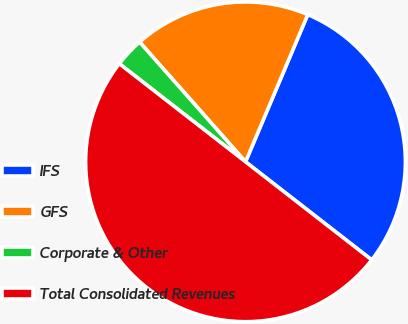Convert chart to OTSL. <chart><loc_0><loc_0><loc_500><loc_500><pie_chart><fcel>IFS<fcel>GFS<fcel>Corporate & Other<fcel>Total Consolidated Revenues<nl><fcel>29.15%<fcel>17.89%<fcel>2.96%<fcel>50.0%<nl></chart> 